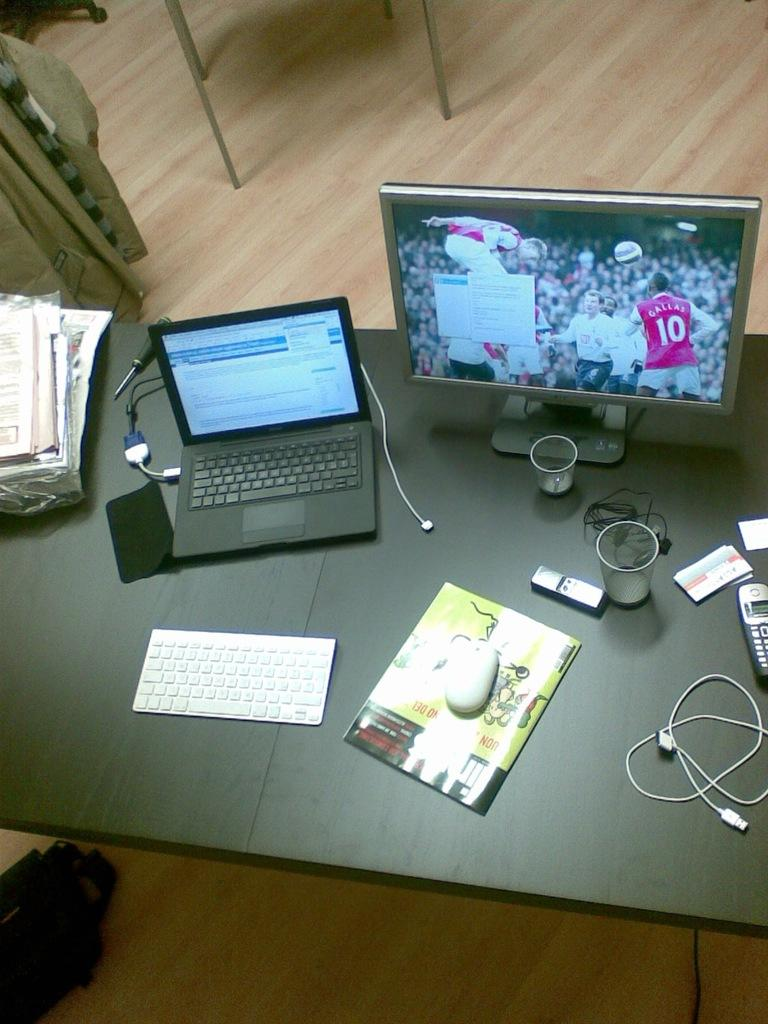<image>
Offer a succinct explanation of the picture presented. A player wearing a red shirt with the name Gallas and the number 10 showing on a computer screen. 